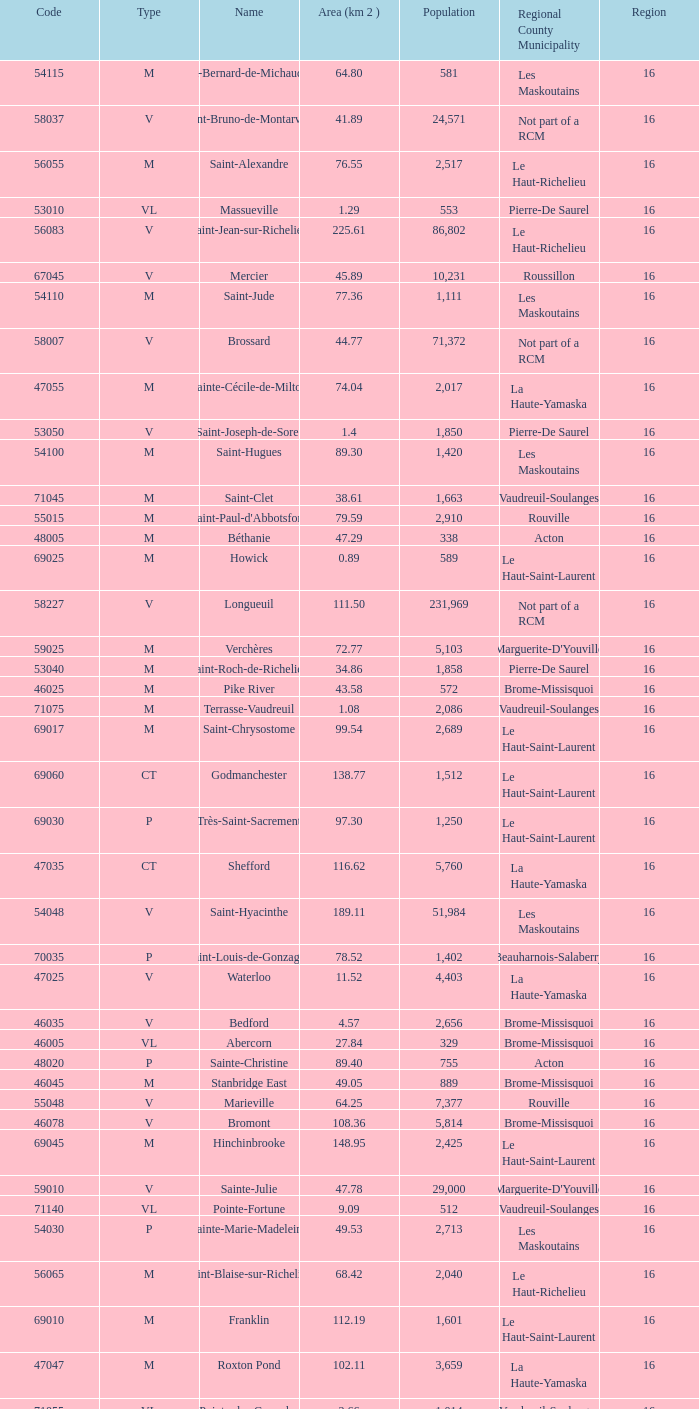What is the code for a Le Haut-Saint-Laurent municipality that has 16 or more regions? None. 